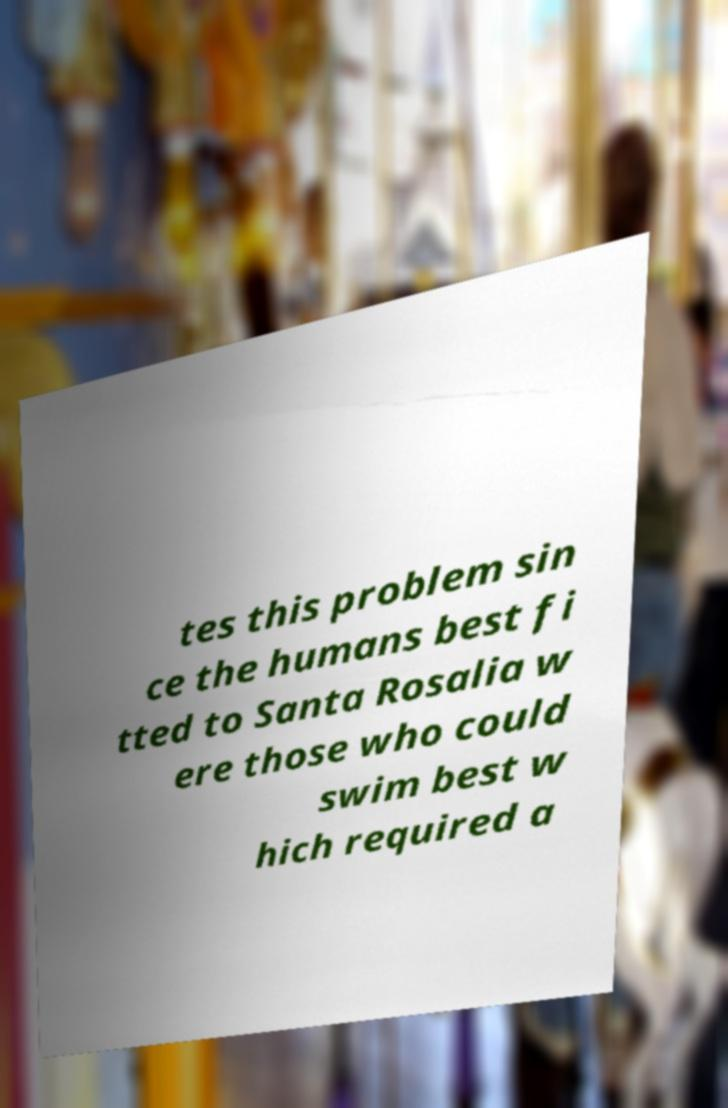Please read and relay the text visible in this image. What does it say? tes this problem sin ce the humans best fi tted to Santa Rosalia w ere those who could swim best w hich required a 